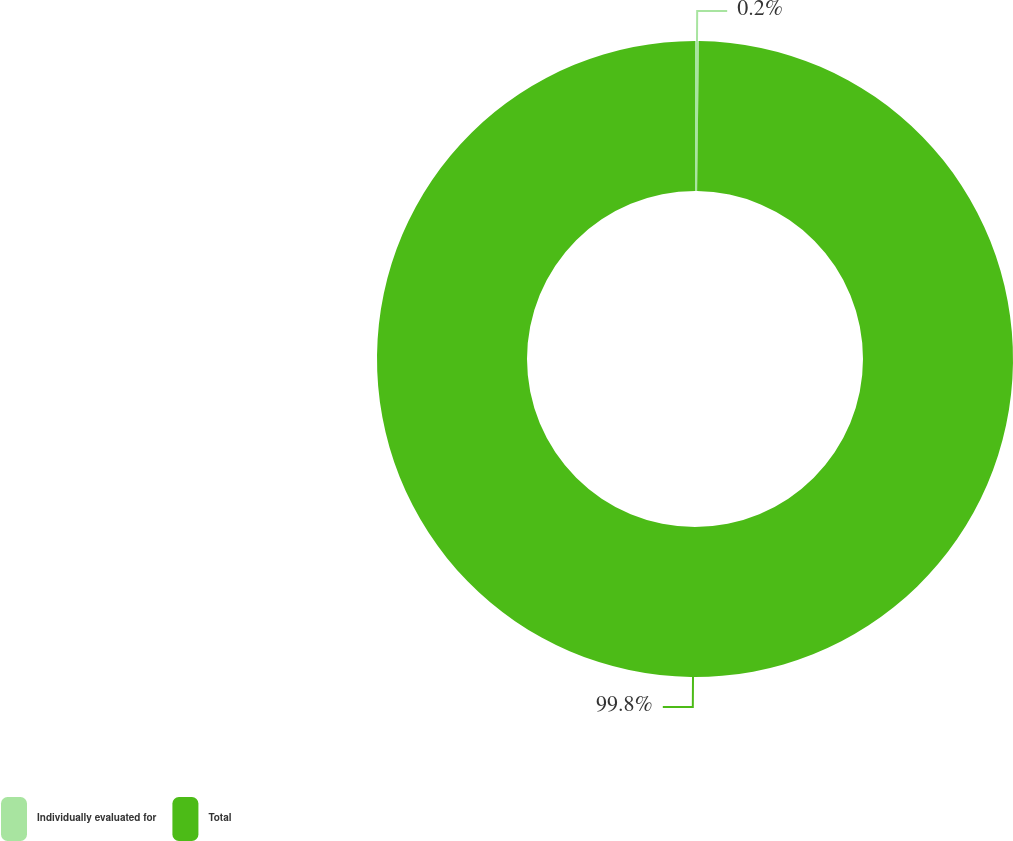<chart> <loc_0><loc_0><loc_500><loc_500><pie_chart><fcel>Individually evaluated for<fcel>Total<nl><fcel>0.2%<fcel>99.8%<nl></chart> 